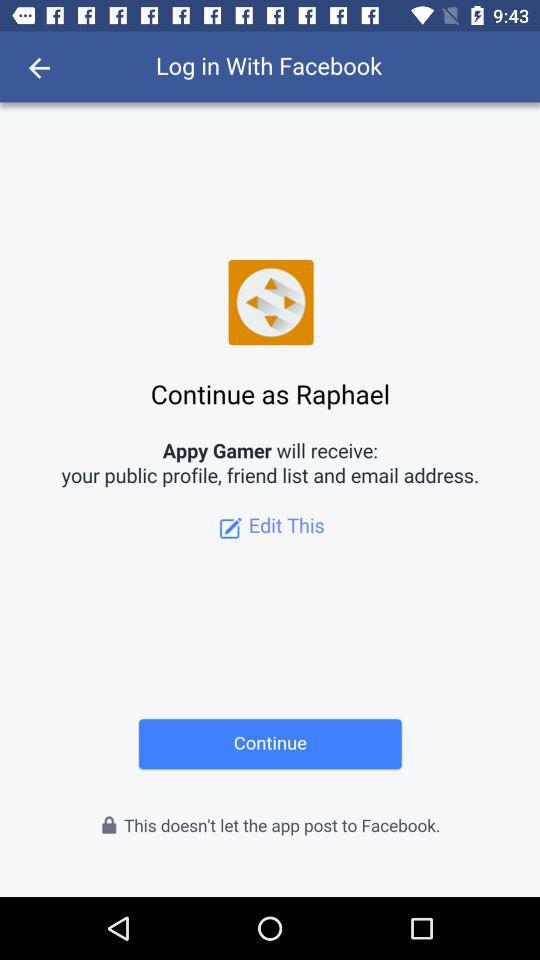What is the user name? The user name is Raphael. 